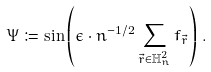<formula> <loc_0><loc_0><loc_500><loc_500>\Psi \coloneqq \sin \left ( \epsilon \cdot n ^ { - 1 / 2 } \sum _ { \vec { r } \in \mathbb { H } _ { n } ^ { 2 } } f _ { \vec { r } } \right ) \, .</formula> 